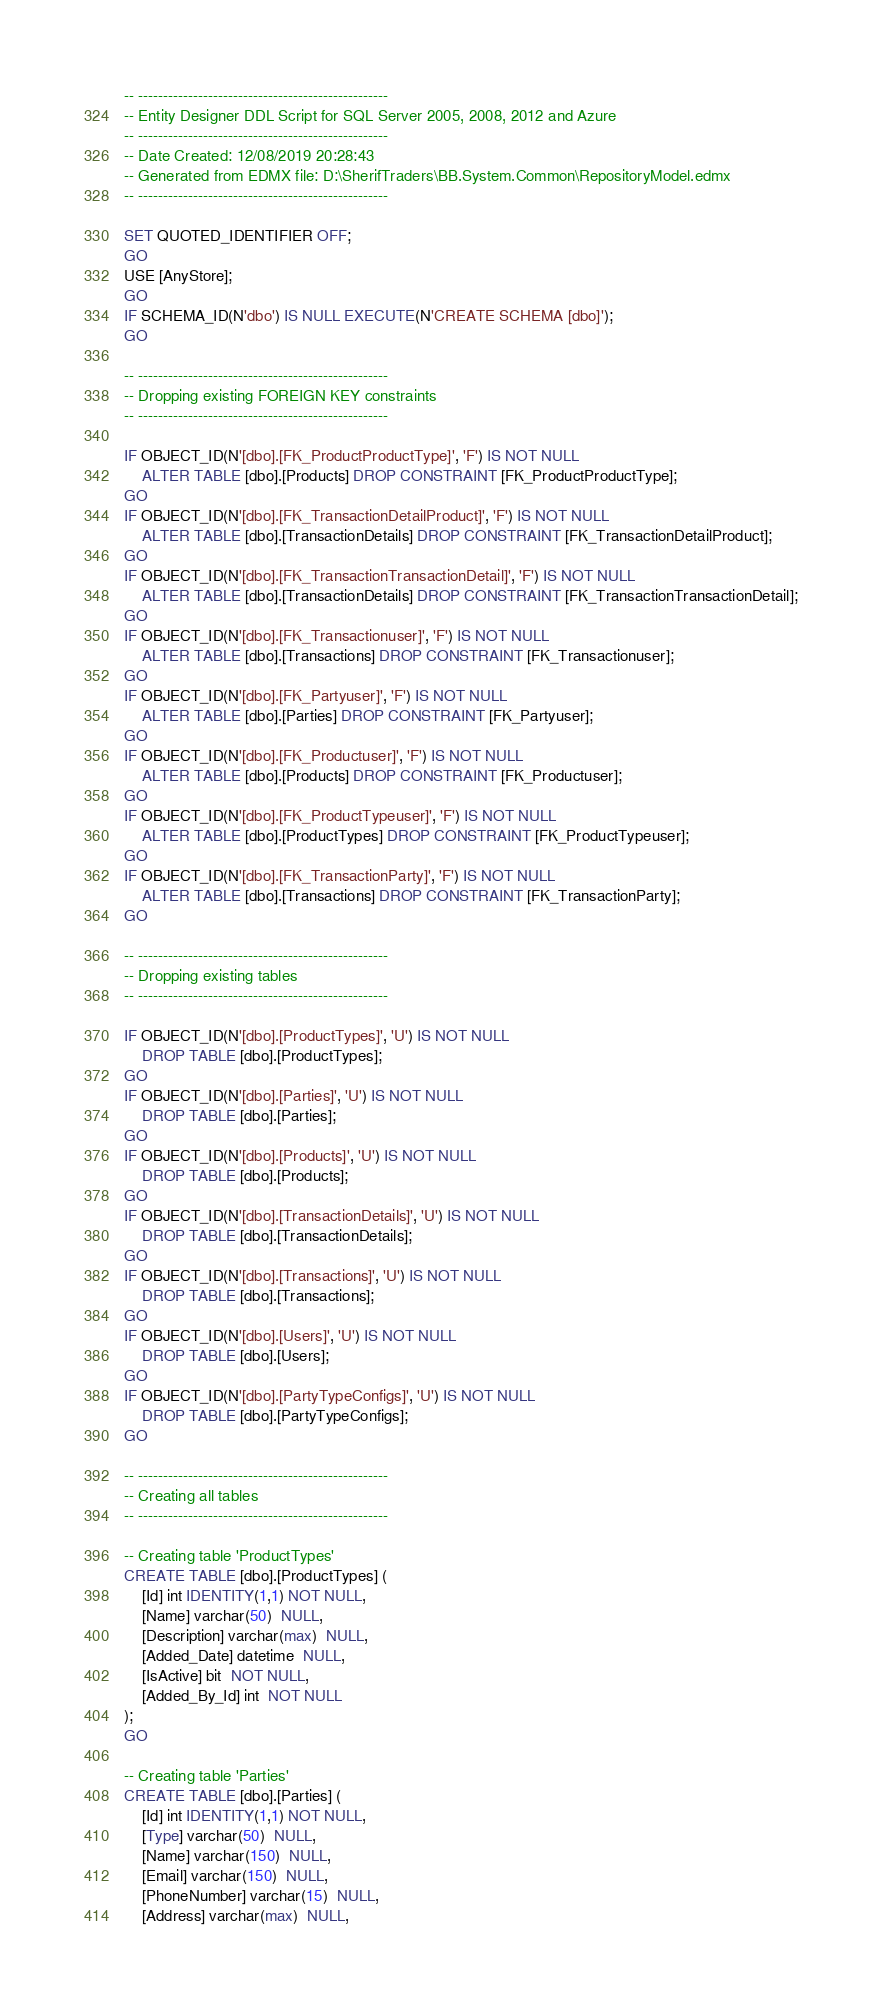<code> <loc_0><loc_0><loc_500><loc_500><_SQL_>
-- --------------------------------------------------
-- Entity Designer DDL Script for SQL Server 2005, 2008, 2012 and Azure
-- --------------------------------------------------
-- Date Created: 12/08/2019 20:28:43
-- Generated from EDMX file: D:\SherifTraders\BB.System.Common\RepositoryModel.edmx
-- --------------------------------------------------

SET QUOTED_IDENTIFIER OFF;
GO
USE [AnyStore];
GO
IF SCHEMA_ID(N'dbo') IS NULL EXECUTE(N'CREATE SCHEMA [dbo]');
GO

-- --------------------------------------------------
-- Dropping existing FOREIGN KEY constraints
-- --------------------------------------------------

IF OBJECT_ID(N'[dbo].[FK_ProductProductType]', 'F') IS NOT NULL
    ALTER TABLE [dbo].[Products] DROP CONSTRAINT [FK_ProductProductType];
GO
IF OBJECT_ID(N'[dbo].[FK_TransactionDetailProduct]', 'F') IS NOT NULL
    ALTER TABLE [dbo].[TransactionDetails] DROP CONSTRAINT [FK_TransactionDetailProduct];
GO
IF OBJECT_ID(N'[dbo].[FK_TransactionTransactionDetail]', 'F') IS NOT NULL
    ALTER TABLE [dbo].[TransactionDetails] DROP CONSTRAINT [FK_TransactionTransactionDetail];
GO
IF OBJECT_ID(N'[dbo].[FK_Transactionuser]', 'F') IS NOT NULL
    ALTER TABLE [dbo].[Transactions] DROP CONSTRAINT [FK_Transactionuser];
GO
IF OBJECT_ID(N'[dbo].[FK_Partyuser]', 'F') IS NOT NULL
    ALTER TABLE [dbo].[Parties] DROP CONSTRAINT [FK_Partyuser];
GO
IF OBJECT_ID(N'[dbo].[FK_Productuser]', 'F') IS NOT NULL
    ALTER TABLE [dbo].[Products] DROP CONSTRAINT [FK_Productuser];
GO
IF OBJECT_ID(N'[dbo].[FK_ProductTypeuser]', 'F') IS NOT NULL
    ALTER TABLE [dbo].[ProductTypes] DROP CONSTRAINT [FK_ProductTypeuser];
GO
IF OBJECT_ID(N'[dbo].[FK_TransactionParty]', 'F') IS NOT NULL
    ALTER TABLE [dbo].[Transactions] DROP CONSTRAINT [FK_TransactionParty];
GO

-- --------------------------------------------------
-- Dropping existing tables
-- --------------------------------------------------

IF OBJECT_ID(N'[dbo].[ProductTypes]', 'U') IS NOT NULL
    DROP TABLE [dbo].[ProductTypes];
GO
IF OBJECT_ID(N'[dbo].[Parties]', 'U') IS NOT NULL
    DROP TABLE [dbo].[Parties];
GO
IF OBJECT_ID(N'[dbo].[Products]', 'U') IS NOT NULL
    DROP TABLE [dbo].[Products];
GO
IF OBJECT_ID(N'[dbo].[TransactionDetails]', 'U') IS NOT NULL
    DROP TABLE [dbo].[TransactionDetails];
GO
IF OBJECT_ID(N'[dbo].[Transactions]', 'U') IS NOT NULL
    DROP TABLE [dbo].[Transactions];
GO
IF OBJECT_ID(N'[dbo].[Users]', 'U') IS NOT NULL
    DROP TABLE [dbo].[Users];
GO
IF OBJECT_ID(N'[dbo].[PartyTypeConfigs]', 'U') IS NOT NULL
    DROP TABLE [dbo].[PartyTypeConfigs];
GO

-- --------------------------------------------------
-- Creating all tables
-- --------------------------------------------------

-- Creating table 'ProductTypes'
CREATE TABLE [dbo].[ProductTypes] (
    [Id] int IDENTITY(1,1) NOT NULL,
    [Name] varchar(50)  NULL,
    [Description] varchar(max)  NULL,
    [Added_Date] datetime  NULL,
    [IsActive] bit  NOT NULL,
    [Added_By_Id] int  NOT NULL
);
GO

-- Creating table 'Parties'
CREATE TABLE [dbo].[Parties] (
    [Id] int IDENTITY(1,1) NOT NULL,
    [Type] varchar(50)  NULL,
    [Name] varchar(150)  NULL,
    [Email] varchar(150)  NULL,
    [PhoneNumber] varchar(15)  NULL,
    [Address] varchar(max)  NULL,</code> 